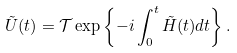<formula> <loc_0><loc_0><loc_500><loc_500>\tilde { U } ( t ) = \mathcal { T } \exp \left \{ - i \int _ { 0 } ^ { t } \tilde { H } ( t ) d t \right \} .</formula> 